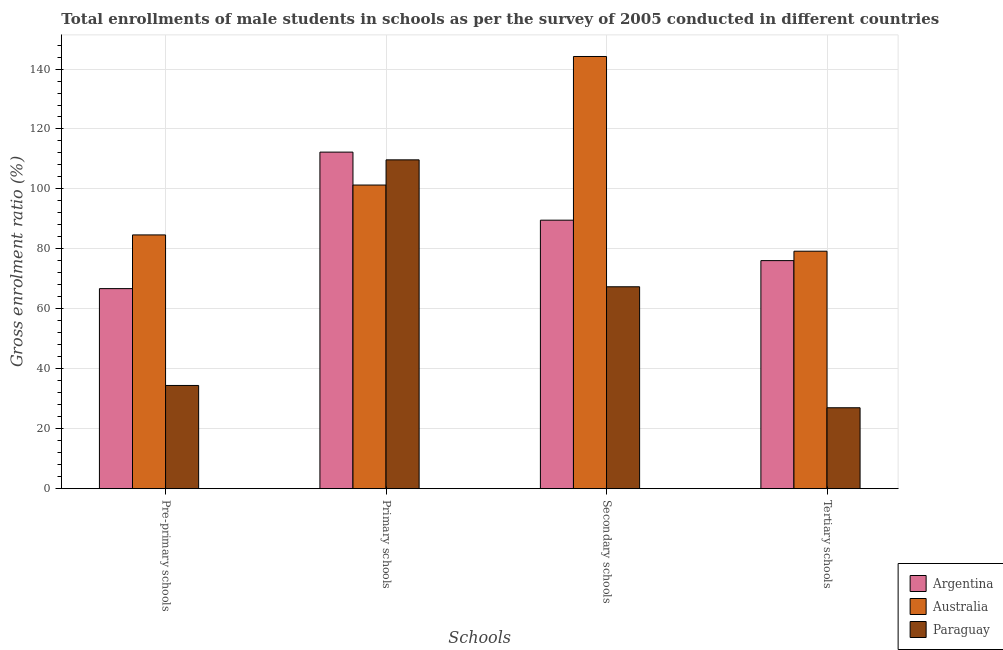How many groups of bars are there?
Offer a very short reply. 4. Are the number of bars per tick equal to the number of legend labels?
Ensure brevity in your answer.  Yes. What is the label of the 2nd group of bars from the left?
Provide a succinct answer. Primary schools. What is the gross enrolment ratio(male) in secondary schools in Argentina?
Your answer should be compact. 89.57. Across all countries, what is the maximum gross enrolment ratio(male) in pre-primary schools?
Your answer should be compact. 84.66. Across all countries, what is the minimum gross enrolment ratio(male) in primary schools?
Ensure brevity in your answer.  101.3. In which country was the gross enrolment ratio(male) in pre-primary schools minimum?
Your response must be concise. Paraguay. What is the total gross enrolment ratio(male) in pre-primary schools in the graph?
Your answer should be compact. 185.83. What is the difference between the gross enrolment ratio(male) in secondary schools in Paraguay and that in Australia?
Offer a terse response. -76.83. What is the difference between the gross enrolment ratio(male) in secondary schools in Argentina and the gross enrolment ratio(male) in pre-primary schools in Paraguay?
Ensure brevity in your answer.  55.14. What is the average gross enrolment ratio(male) in primary schools per country?
Your response must be concise. 107.76. What is the difference between the gross enrolment ratio(male) in primary schools and gross enrolment ratio(male) in tertiary schools in Argentina?
Give a very brief answer. 36.2. What is the ratio of the gross enrolment ratio(male) in primary schools in Paraguay to that in Argentina?
Keep it short and to the point. 0.98. Is the difference between the gross enrolment ratio(male) in secondary schools in Australia and Paraguay greater than the difference between the gross enrolment ratio(male) in pre-primary schools in Australia and Paraguay?
Offer a very short reply. Yes. What is the difference between the highest and the second highest gross enrolment ratio(male) in pre-primary schools?
Your answer should be very brief. 17.91. What is the difference between the highest and the lowest gross enrolment ratio(male) in tertiary schools?
Keep it short and to the point. 52.23. In how many countries, is the gross enrolment ratio(male) in pre-primary schools greater than the average gross enrolment ratio(male) in pre-primary schools taken over all countries?
Ensure brevity in your answer.  2. Is it the case that in every country, the sum of the gross enrolment ratio(male) in secondary schools and gross enrolment ratio(male) in primary schools is greater than the sum of gross enrolment ratio(male) in tertiary schools and gross enrolment ratio(male) in pre-primary schools?
Give a very brief answer. Yes. What does the 3rd bar from the right in Primary schools represents?
Make the answer very short. Argentina. Is it the case that in every country, the sum of the gross enrolment ratio(male) in pre-primary schools and gross enrolment ratio(male) in primary schools is greater than the gross enrolment ratio(male) in secondary schools?
Offer a terse response. Yes. How many bars are there?
Offer a terse response. 12. What is the difference between two consecutive major ticks on the Y-axis?
Offer a terse response. 20. Does the graph contain grids?
Keep it short and to the point. Yes. What is the title of the graph?
Offer a very short reply. Total enrollments of male students in schools as per the survey of 2005 conducted in different countries. Does "Eritrea" appear as one of the legend labels in the graph?
Make the answer very short. No. What is the label or title of the X-axis?
Give a very brief answer. Schools. What is the Gross enrolment ratio (%) in Argentina in Pre-primary schools?
Your answer should be compact. 66.74. What is the Gross enrolment ratio (%) of Australia in Pre-primary schools?
Your answer should be very brief. 84.66. What is the Gross enrolment ratio (%) in Paraguay in Pre-primary schools?
Ensure brevity in your answer.  34.43. What is the Gross enrolment ratio (%) in Argentina in Primary schools?
Provide a succinct answer. 112.28. What is the Gross enrolment ratio (%) in Australia in Primary schools?
Provide a short and direct response. 101.3. What is the Gross enrolment ratio (%) in Paraguay in Primary schools?
Offer a very short reply. 109.7. What is the Gross enrolment ratio (%) of Argentina in Secondary schools?
Offer a very short reply. 89.57. What is the Gross enrolment ratio (%) of Australia in Secondary schools?
Keep it short and to the point. 144.19. What is the Gross enrolment ratio (%) of Paraguay in Secondary schools?
Your answer should be compact. 67.36. What is the Gross enrolment ratio (%) of Argentina in Tertiary schools?
Give a very brief answer. 76.08. What is the Gross enrolment ratio (%) in Australia in Tertiary schools?
Make the answer very short. 79.22. What is the Gross enrolment ratio (%) of Paraguay in Tertiary schools?
Provide a short and direct response. 27. Across all Schools, what is the maximum Gross enrolment ratio (%) of Argentina?
Make the answer very short. 112.28. Across all Schools, what is the maximum Gross enrolment ratio (%) of Australia?
Offer a terse response. 144.19. Across all Schools, what is the maximum Gross enrolment ratio (%) in Paraguay?
Give a very brief answer. 109.7. Across all Schools, what is the minimum Gross enrolment ratio (%) of Argentina?
Provide a succinct answer. 66.74. Across all Schools, what is the minimum Gross enrolment ratio (%) of Australia?
Your answer should be compact. 79.22. Across all Schools, what is the minimum Gross enrolment ratio (%) of Paraguay?
Offer a terse response. 27. What is the total Gross enrolment ratio (%) in Argentina in the graph?
Offer a very short reply. 344.68. What is the total Gross enrolment ratio (%) in Australia in the graph?
Keep it short and to the point. 409.37. What is the total Gross enrolment ratio (%) in Paraguay in the graph?
Provide a succinct answer. 238.49. What is the difference between the Gross enrolment ratio (%) in Argentina in Pre-primary schools and that in Primary schools?
Keep it short and to the point. -45.54. What is the difference between the Gross enrolment ratio (%) of Australia in Pre-primary schools and that in Primary schools?
Ensure brevity in your answer.  -16.64. What is the difference between the Gross enrolment ratio (%) in Paraguay in Pre-primary schools and that in Primary schools?
Keep it short and to the point. -75.27. What is the difference between the Gross enrolment ratio (%) in Argentina in Pre-primary schools and that in Secondary schools?
Provide a short and direct response. -22.83. What is the difference between the Gross enrolment ratio (%) in Australia in Pre-primary schools and that in Secondary schools?
Your response must be concise. -59.53. What is the difference between the Gross enrolment ratio (%) in Paraguay in Pre-primary schools and that in Secondary schools?
Your answer should be very brief. -32.93. What is the difference between the Gross enrolment ratio (%) in Argentina in Pre-primary schools and that in Tertiary schools?
Make the answer very short. -9.34. What is the difference between the Gross enrolment ratio (%) in Australia in Pre-primary schools and that in Tertiary schools?
Your response must be concise. 5.44. What is the difference between the Gross enrolment ratio (%) in Paraguay in Pre-primary schools and that in Tertiary schools?
Offer a very short reply. 7.44. What is the difference between the Gross enrolment ratio (%) of Argentina in Primary schools and that in Secondary schools?
Offer a terse response. 22.71. What is the difference between the Gross enrolment ratio (%) of Australia in Primary schools and that in Secondary schools?
Your answer should be compact. -42.89. What is the difference between the Gross enrolment ratio (%) in Paraguay in Primary schools and that in Secondary schools?
Offer a terse response. 42.34. What is the difference between the Gross enrolment ratio (%) of Argentina in Primary schools and that in Tertiary schools?
Your answer should be compact. 36.2. What is the difference between the Gross enrolment ratio (%) of Australia in Primary schools and that in Tertiary schools?
Provide a succinct answer. 22.08. What is the difference between the Gross enrolment ratio (%) of Paraguay in Primary schools and that in Tertiary schools?
Ensure brevity in your answer.  82.71. What is the difference between the Gross enrolment ratio (%) of Argentina in Secondary schools and that in Tertiary schools?
Offer a terse response. 13.49. What is the difference between the Gross enrolment ratio (%) of Australia in Secondary schools and that in Tertiary schools?
Your response must be concise. 64.96. What is the difference between the Gross enrolment ratio (%) in Paraguay in Secondary schools and that in Tertiary schools?
Give a very brief answer. 40.36. What is the difference between the Gross enrolment ratio (%) of Argentina in Pre-primary schools and the Gross enrolment ratio (%) of Australia in Primary schools?
Make the answer very short. -34.56. What is the difference between the Gross enrolment ratio (%) of Argentina in Pre-primary schools and the Gross enrolment ratio (%) of Paraguay in Primary schools?
Provide a short and direct response. -42.96. What is the difference between the Gross enrolment ratio (%) in Australia in Pre-primary schools and the Gross enrolment ratio (%) in Paraguay in Primary schools?
Your answer should be very brief. -25.05. What is the difference between the Gross enrolment ratio (%) of Argentina in Pre-primary schools and the Gross enrolment ratio (%) of Australia in Secondary schools?
Keep it short and to the point. -77.44. What is the difference between the Gross enrolment ratio (%) in Argentina in Pre-primary schools and the Gross enrolment ratio (%) in Paraguay in Secondary schools?
Your answer should be very brief. -0.62. What is the difference between the Gross enrolment ratio (%) in Australia in Pre-primary schools and the Gross enrolment ratio (%) in Paraguay in Secondary schools?
Keep it short and to the point. 17.3. What is the difference between the Gross enrolment ratio (%) of Argentina in Pre-primary schools and the Gross enrolment ratio (%) of Australia in Tertiary schools?
Provide a succinct answer. -12.48. What is the difference between the Gross enrolment ratio (%) of Argentina in Pre-primary schools and the Gross enrolment ratio (%) of Paraguay in Tertiary schools?
Offer a very short reply. 39.75. What is the difference between the Gross enrolment ratio (%) in Australia in Pre-primary schools and the Gross enrolment ratio (%) in Paraguay in Tertiary schools?
Ensure brevity in your answer.  57.66. What is the difference between the Gross enrolment ratio (%) in Argentina in Primary schools and the Gross enrolment ratio (%) in Australia in Secondary schools?
Make the answer very short. -31.91. What is the difference between the Gross enrolment ratio (%) in Argentina in Primary schools and the Gross enrolment ratio (%) in Paraguay in Secondary schools?
Offer a terse response. 44.92. What is the difference between the Gross enrolment ratio (%) in Australia in Primary schools and the Gross enrolment ratio (%) in Paraguay in Secondary schools?
Ensure brevity in your answer.  33.94. What is the difference between the Gross enrolment ratio (%) of Argentina in Primary schools and the Gross enrolment ratio (%) of Australia in Tertiary schools?
Give a very brief answer. 33.06. What is the difference between the Gross enrolment ratio (%) in Argentina in Primary schools and the Gross enrolment ratio (%) in Paraguay in Tertiary schools?
Provide a succinct answer. 85.28. What is the difference between the Gross enrolment ratio (%) in Australia in Primary schools and the Gross enrolment ratio (%) in Paraguay in Tertiary schools?
Provide a short and direct response. 74.3. What is the difference between the Gross enrolment ratio (%) in Argentina in Secondary schools and the Gross enrolment ratio (%) in Australia in Tertiary schools?
Your response must be concise. 10.35. What is the difference between the Gross enrolment ratio (%) of Argentina in Secondary schools and the Gross enrolment ratio (%) of Paraguay in Tertiary schools?
Give a very brief answer. 62.58. What is the difference between the Gross enrolment ratio (%) in Australia in Secondary schools and the Gross enrolment ratio (%) in Paraguay in Tertiary schools?
Give a very brief answer. 117.19. What is the average Gross enrolment ratio (%) in Argentina per Schools?
Keep it short and to the point. 86.17. What is the average Gross enrolment ratio (%) of Australia per Schools?
Keep it short and to the point. 102.34. What is the average Gross enrolment ratio (%) in Paraguay per Schools?
Give a very brief answer. 59.62. What is the difference between the Gross enrolment ratio (%) in Argentina and Gross enrolment ratio (%) in Australia in Pre-primary schools?
Your answer should be very brief. -17.91. What is the difference between the Gross enrolment ratio (%) of Argentina and Gross enrolment ratio (%) of Paraguay in Pre-primary schools?
Offer a very short reply. 32.31. What is the difference between the Gross enrolment ratio (%) of Australia and Gross enrolment ratio (%) of Paraguay in Pre-primary schools?
Keep it short and to the point. 50.23. What is the difference between the Gross enrolment ratio (%) of Argentina and Gross enrolment ratio (%) of Australia in Primary schools?
Provide a succinct answer. 10.98. What is the difference between the Gross enrolment ratio (%) in Argentina and Gross enrolment ratio (%) in Paraguay in Primary schools?
Your response must be concise. 2.58. What is the difference between the Gross enrolment ratio (%) of Australia and Gross enrolment ratio (%) of Paraguay in Primary schools?
Ensure brevity in your answer.  -8.4. What is the difference between the Gross enrolment ratio (%) in Argentina and Gross enrolment ratio (%) in Australia in Secondary schools?
Provide a succinct answer. -54.61. What is the difference between the Gross enrolment ratio (%) of Argentina and Gross enrolment ratio (%) of Paraguay in Secondary schools?
Provide a succinct answer. 22.21. What is the difference between the Gross enrolment ratio (%) of Australia and Gross enrolment ratio (%) of Paraguay in Secondary schools?
Offer a terse response. 76.83. What is the difference between the Gross enrolment ratio (%) of Argentina and Gross enrolment ratio (%) of Australia in Tertiary schools?
Provide a short and direct response. -3.14. What is the difference between the Gross enrolment ratio (%) of Argentina and Gross enrolment ratio (%) of Paraguay in Tertiary schools?
Offer a terse response. 49.09. What is the difference between the Gross enrolment ratio (%) of Australia and Gross enrolment ratio (%) of Paraguay in Tertiary schools?
Offer a terse response. 52.23. What is the ratio of the Gross enrolment ratio (%) of Argentina in Pre-primary schools to that in Primary schools?
Keep it short and to the point. 0.59. What is the ratio of the Gross enrolment ratio (%) in Australia in Pre-primary schools to that in Primary schools?
Your answer should be very brief. 0.84. What is the ratio of the Gross enrolment ratio (%) of Paraguay in Pre-primary schools to that in Primary schools?
Offer a very short reply. 0.31. What is the ratio of the Gross enrolment ratio (%) of Argentina in Pre-primary schools to that in Secondary schools?
Provide a short and direct response. 0.75. What is the ratio of the Gross enrolment ratio (%) of Australia in Pre-primary schools to that in Secondary schools?
Give a very brief answer. 0.59. What is the ratio of the Gross enrolment ratio (%) of Paraguay in Pre-primary schools to that in Secondary schools?
Provide a succinct answer. 0.51. What is the ratio of the Gross enrolment ratio (%) of Argentina in Pre-primary schools to that in Tertiary schools?
Provide a short and direct response. 0.88. What is the ratio of the Gross enrolment ratio (%) of Australia in Pre-primary schools to that in Tertiary schools?
Your answer should be very brief. 1.07. What is the ratio of the Gross enrolment ratio (%) of Paraguay in Pre-primary schools to that in Tertiary schools?
Ensure brevity in your answer.  1.28. What is the ratio of the Gross enrolment ratio (%) of Argentina in Primary schools to that in Secondary schools?
Give a very brief answer. 1.25. What is the ratio of the Gross enrolment ratio (%) in Australia in Primary schools to that in Secondary schools?
Ensure brevity in your answer.  0.7. What is the ratio of the Gross enrolment ratio (%) of Paraguay in Primary schools to that in Secondary schools?
Keep it short and to the point. 1.63. What is the ratio of the Gross enrolment ratio (%) in Argentina in Primary schools to that in Tertiary schools?
Offer a very short reply. 1.48. What is the ratio of the Gross enrolment ratio (%) of Australia in Primary schools to that in Tertiary schools?
Offer a very short reply. 1.28. What is the ratio of the Gross enrolment ratio (%) of Paraguay in Primary schools to that in Tertiary schools?
Keep it short and to the point. 4.06. What is the ratio of the Gross enrolment ratio (%) in Argentina in Secondary schools to that in Tertiary schools?
Your answer should be compact. 1.18. What is the ratio of the Gross enrolment ratio (%) of Australia in Secondary schools to that in Tertiary schools?
Keep it short and to the point. 1.82. What is the ratio of the Gross enrolment ratio (%) in Paraguay in Secondary schools to that in Tertiary schools?
Provide a succinct answer. 2.5. What is the difference between the highest and the second highest Gross enrolment ratio (%) of Argentina?
Make the answer very short. 22.71. What is the difference between the highest and the second highest Gross enrolment ratio (%) of Australia?
Your answer should be very brief. 42.89. What is the difference between the highest and the second highest Gross enrolment ratio (%) in Paraguay?
Offer a terse response. 42.34. What is the difference between the highest and the lowest Gross enrolment ratio (%) of Argentina?
Provide a succinct answer. 45.54. What is the difference between the highest and the lowest Gross enrolment ratio (%) in Australia?
Make the answer very short. 64.96. What is the difference between the highest and the lowest Gross enrolment ratio (%) of Paraguay?
Your answer should be compact. 82.71. 